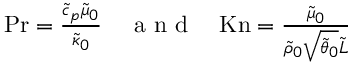<formula> <loc_0><loc_0><loc_500><loc_500>\begin{array} { r } { P r = \frac { \tilde { c } _ { p } \tilde { \mu } _ { 0 } } { \tilde { \kappa } _ { 0 } } \quad a n d \quad K n = \frac { \tilde { \mu } _ { 0 } } { \tilde { \rho } _ { 0 } \sqrt { \tilde { \theta } _ { 0 } } \tilde { L } } } \end{array}</formula> 